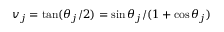Convert formula to latex. <formula><loc_0><loc_0><loc_500><loc_500>v _ { j } = \tan ( \theta _ { j } / 2 ) = \sin \theta _ { j } / ( 1 + \cos \theta _ { j } )</formula> 